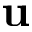<formula> <loc_0><loc_0><loc_500><loc_500>u</formula> 